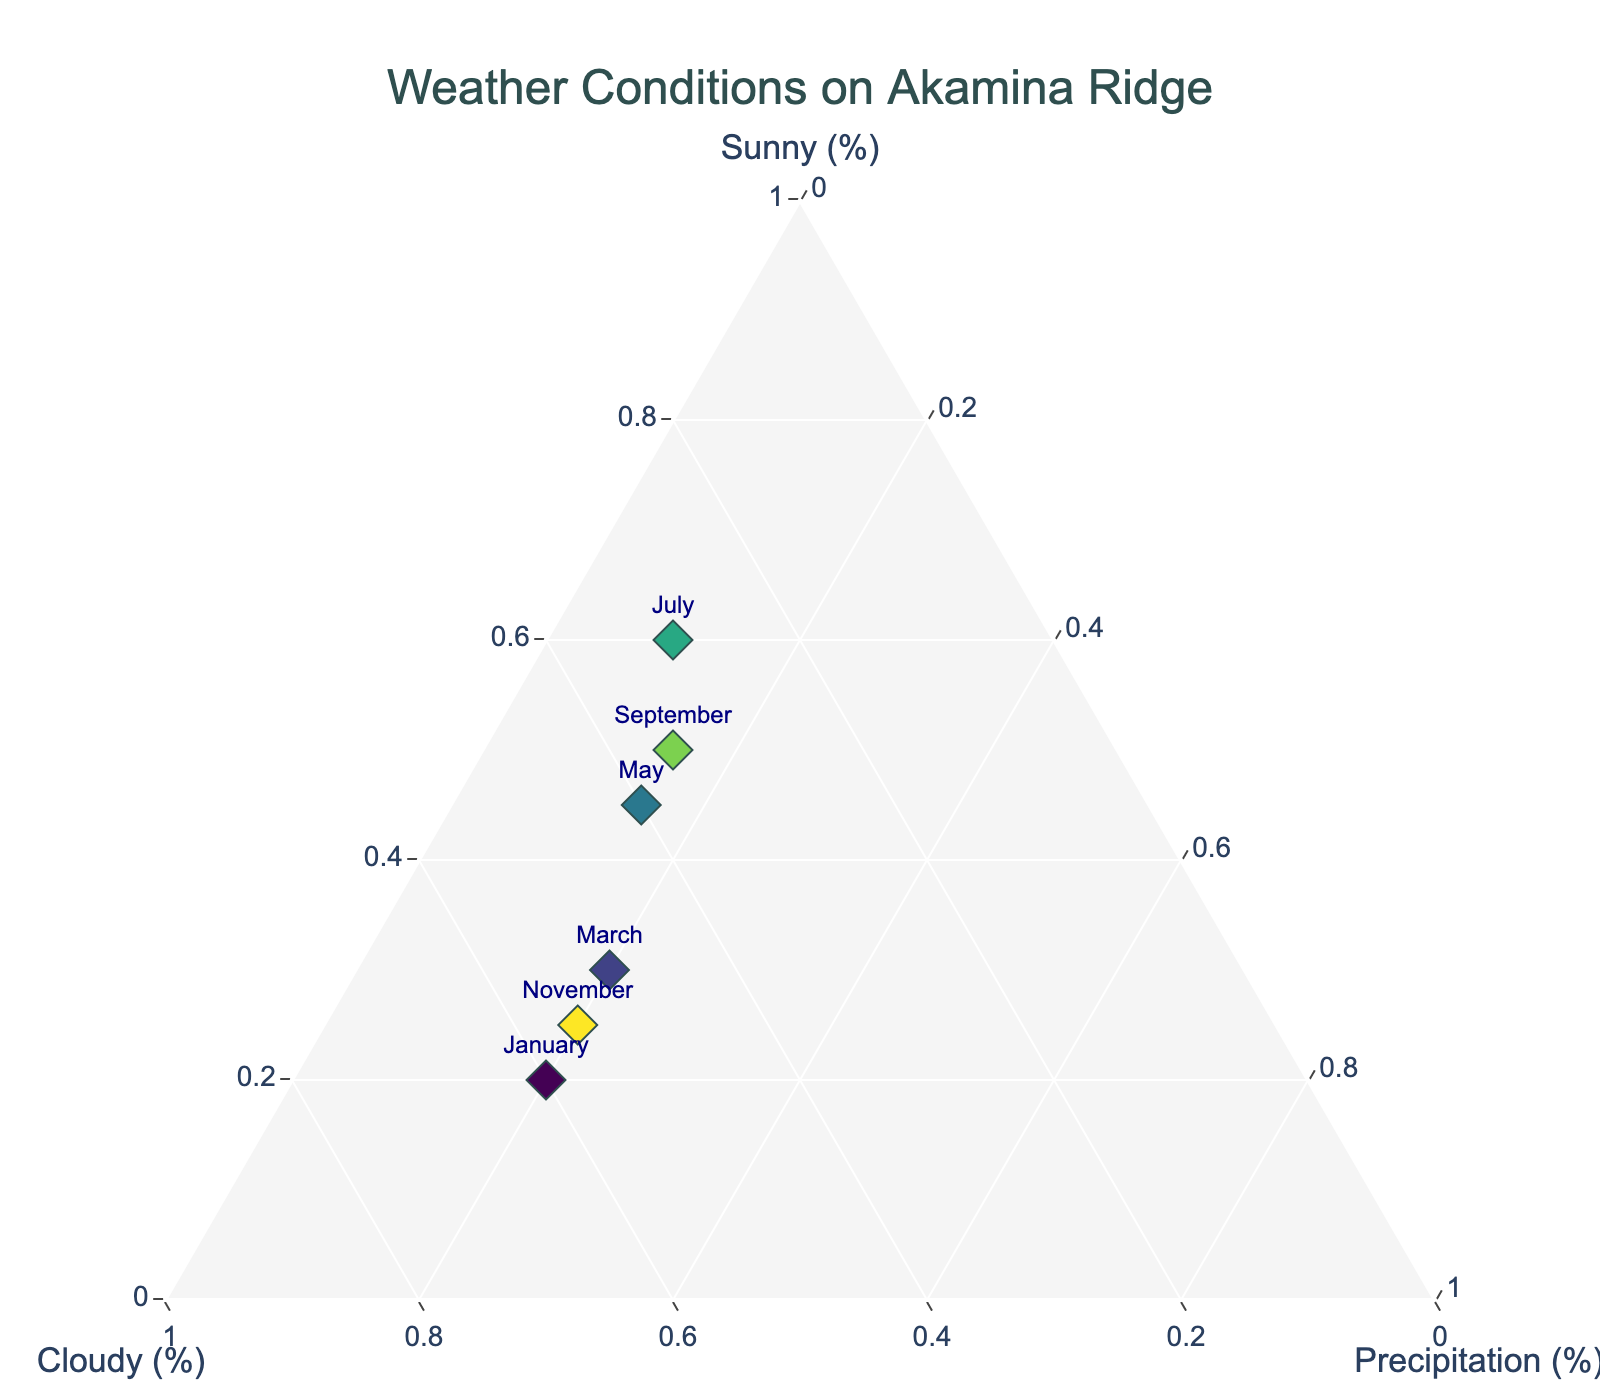what are the months on the Ternary Plot? The text annotations near each marker show the months. They are January, March, May, July, September, and November.
Answer: January, March, May, July, September, November which month has the highest percentage of sunny days? Looking at the "Sunny (%)" axis, July has the highest percentage at 60%.
Answer: July what is the average percentage of precipitation across all the months? Sum the percentages of precipitation (20 + 20 + 15 + 10 + 15 + 20) and divide by the number of months (6). The sum is 100 and the average is 100/6.
Answer: 16.67% Which month has more cloudy days, March or September? Looking at the "Cloudy (%)" axis, March has 50% cloudy days, while September has 35%.
Answer: March what's the total percentage of non-sunny days in November? Add the percentages of cloudy and precipitation in November: 55% (cloudy) + 20% (precipitation). The sum is 75%.
Answer: 75% Which month is closest to having an equal balance of sunny, cloudy, and precipitation? By examining the plot, May appears closest to having more balanced percentages: 45% sunny, 40% cloudy, and 15% precipitation.
Answer: May which month has the lowest percentage of precipitation? From the "Precipitation (%)" axis, July has the lowest percentage at 10%.
Answer: July what is the difference in sunny days between January and May? January has 20% sunny days, and May has 45%. The difference is 45% - 20%.
Answer: 25% Which month has a higher percentage of sunny days, January or November? Comparing both January (20%) and November (25%) on the "Sunny (%)" axis, November has a higher percentage.
Answer: November what trend can you observe about precipitation from January to July? Observing the data points, the percentage of precipitation appears to decrease from January (20%) to July (10%).
Answer: Decreasing 